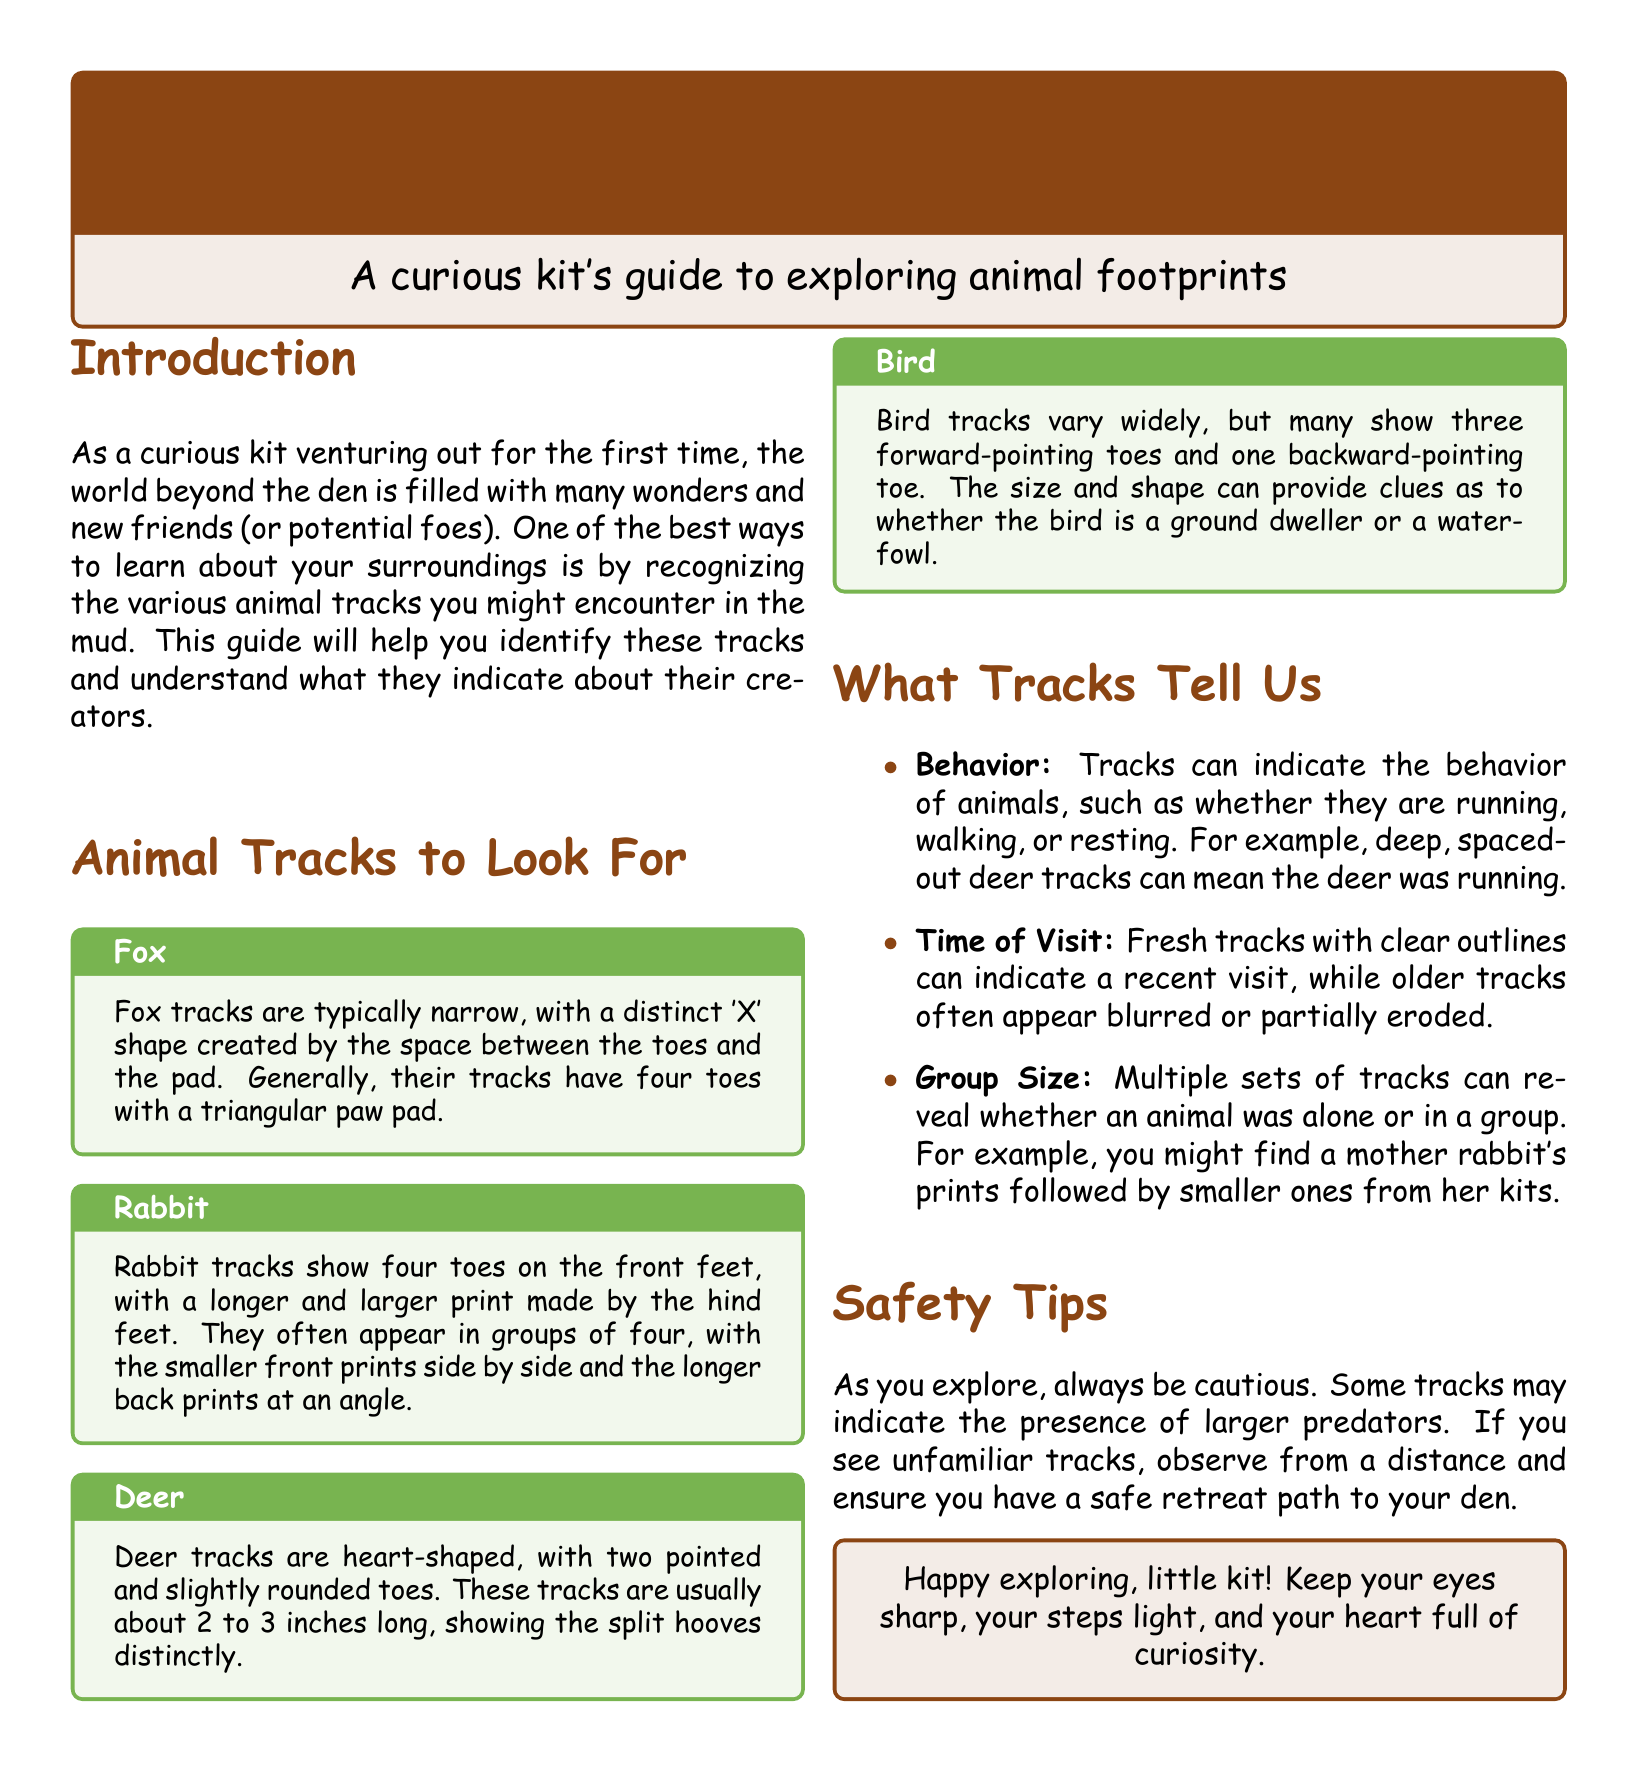What is the title of the guide? The title of the guide is stated at the top of the document.
Answer: Tracks in the Mud: Learning to Identify Friends and Foes How many toes do fox tracks typically have? The fox tracks description specifies the number of toes.
Answer: Four toes What shape are deer tracks? The document describes deer tracks in terms of their shape.
Answer: Heart-shaped Which animal's tracks show three forward-pointing toes? The document mentions the specific animal regarding its track characteristics.
Answer: Bird What can deep, spaced-out deer tracks indicate? The document explains what specific track characteristics indicate about animal behavior.
Answer: Running What color is the background of the safety tips section? The document refers to the color used in the section background.
Answer: Mud color What behavior can tracks suggest? The document lists several types of information that tracks can provide.
Answer: Behavior What should you observe if you see unfamiliar tracks? The advice given in the safety tips discusses how to react to unfamiliar tracks.
Answer: From a distance What is emphasized for the curious kit at the end of the guide? The final note in the document encapsulates the encouragement given to the kit.
Answer: Keep your eyes sharp 